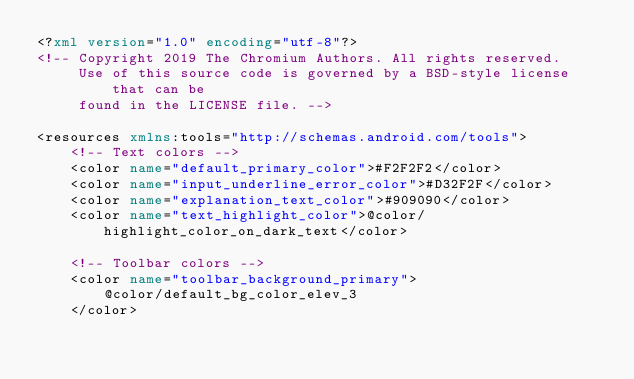<code> <loc_0><loc_0><loc_500><loc_500><_XML_><?xml version="1.0" encoding="utf-8"?>
<!-- Copyright 2019 The Chromium Authors. All rights reserved.
     Use of this source code is governed by a BSD-style license that can be
     found in the LICENSE file. -->

<resources xmlns:tools="http://schemas.android.com/tools">
    <!-- Text colors -->
    <color name="default_primary_color">#F2F2F2</color>
    <color name="input_underline_error_color">#D32F2F</color>
    <color name="explanation_text_color">#909090</color>
    <color name="text_highlight_color">@color/highlight_color_on_dark_text</color>

    <!-- Toolbar colors -->
    <color name="toolbar_background_primary">
        @color/default_bg_color_elev_3
    </color></code> 